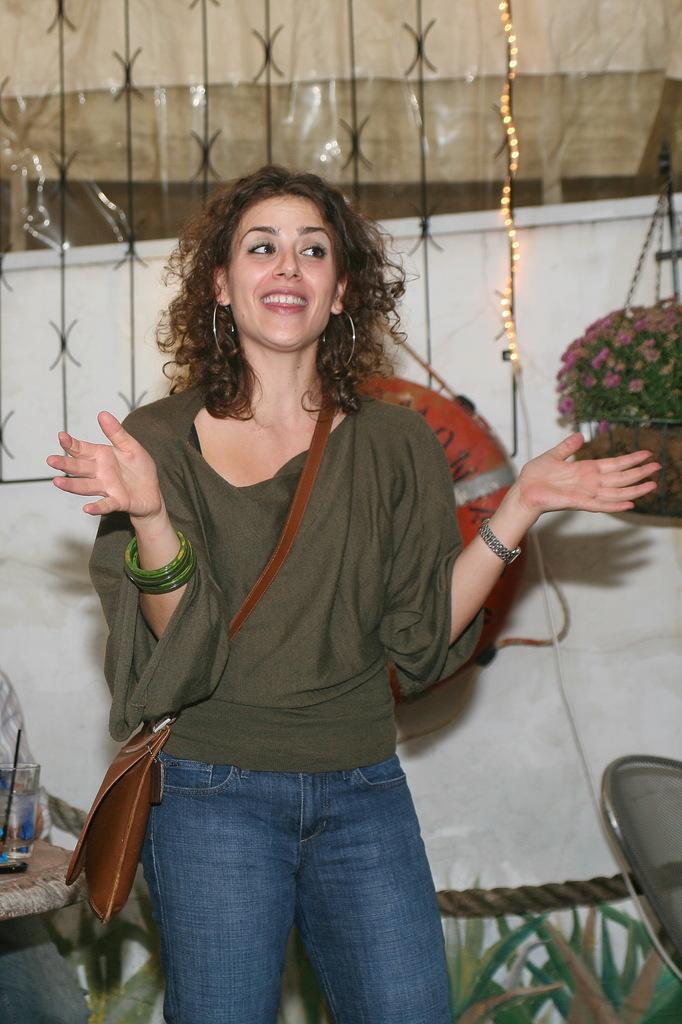In one or two sentences, can you explain what this image depicts? In this picture there is a woman standing and carrying a bag, In the background of the image we can see glass with straw on the table, person, lights, chair, cloth, plant with flowers in a pot, leaves and objects. 